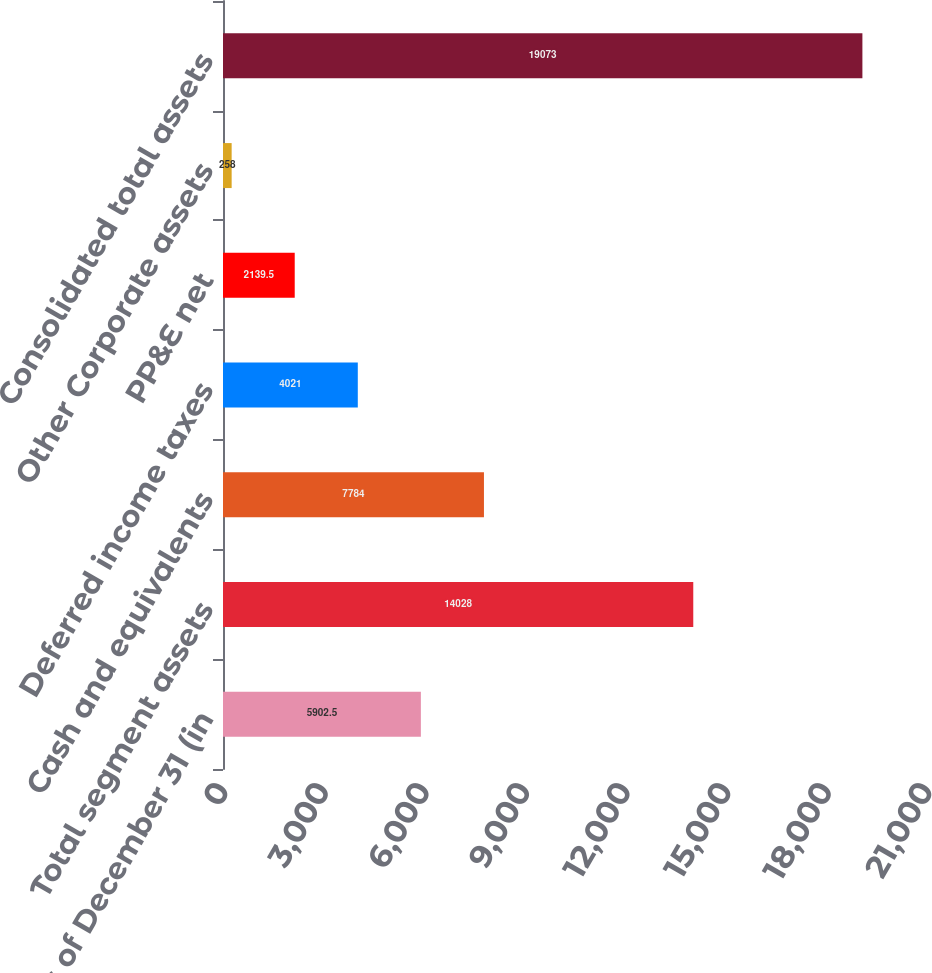Convert chart. <chart><loc_0><loc_0><loc_500><loc_500><bar_chart><fcel>as of December 31 (in<fcel>Total segment assets<fcel>Cash and equivalents<fcel>Deferred income taxes<fcel>PP&E net<fcel>Other Corporate assets<fcel>Consolidated total assets<nl><fcel>5902.5<fcel>14028<fcel>7784<fcel>4021<fcel>2139.5<fcel>258<fcel>19073<nl></chart> 